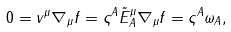Convert formula to latex. <formula><loc_0><loc_0><loc_500><loc_500>0 = v ^ { \mu } \nabla _ { \mu } f = \varsigma ^ { A } \tilde { E } _ { A } ^ { \mu } \nabla _ { \mu } f = \varsigma ^ { A } \omega _ { A } ,</formula> 